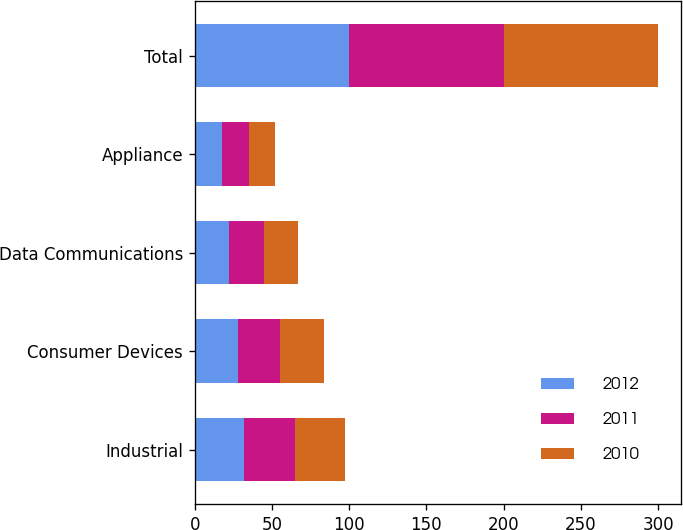<chart> <loc_0><loc_0><loc_500><loc_500><stacked_bar_chart><ecel><fcel>Industrial<fcel>Consumer Devices<fcel>Data Communications<fcel>Appliance<fcel>Total<nl><fcel>2012<fcel>32<fcel>28<fcel>22<fcel>18<fcel>100<nl><fcel>2011<fcel>33<fcel>27<fcel>23<fcel>17<fcel>100<nl><fcel>2010<fcel>32<fcel>29<fcel>22<fcel>17<fcel>100<nl></chart> 